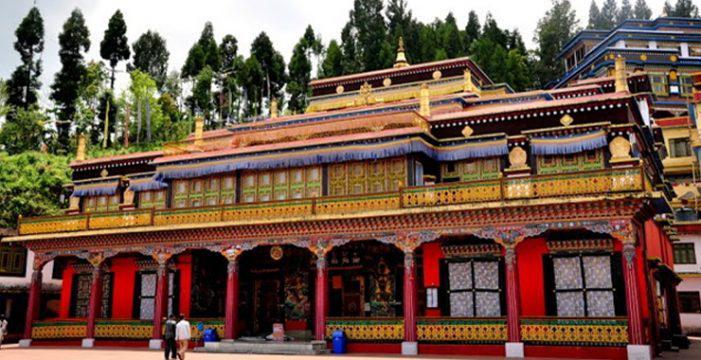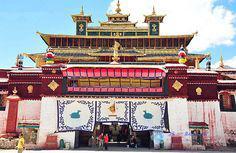The first image is the image on the left, the second image is the image on the right. For the images shown, is this caption "Both buildings have flat roofs with no curves on the sides." true? Answer yes or no. No. The first image is the image on the left, the second image is the image on the right. Evaluate the accuracy of this statement regarding the images: "The left and right image contains the same number of floors in the building.". Is it true? Answer yes or no. Yes. 